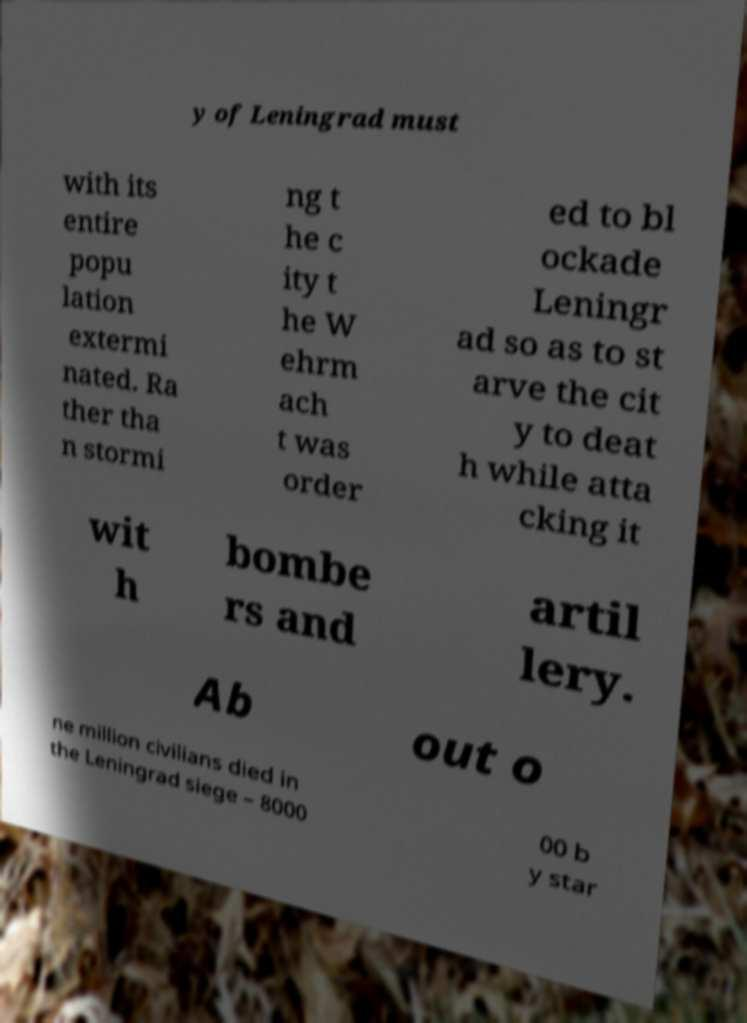For documentation purposes, I need the text within this image transcribed. Could you provide that? y of Leningrad must with its entire popu lation extermi nated. Ra ther tha n stormi ng t he c ity t he W ehrm ach t was order ed to bl ockade Leningr ad so as to st arve the cit y to deat h while atta cking it wit h bombe rs and artil lery. Ab out o ne million civilians died in the Leningrad siege – 8000 00 b y star 